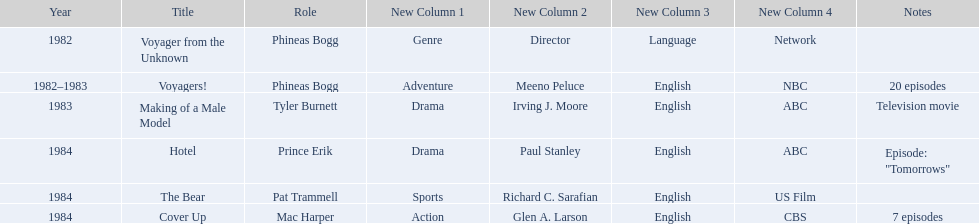In how many titles on this list did he not play the role of phineas bogg? 4. 